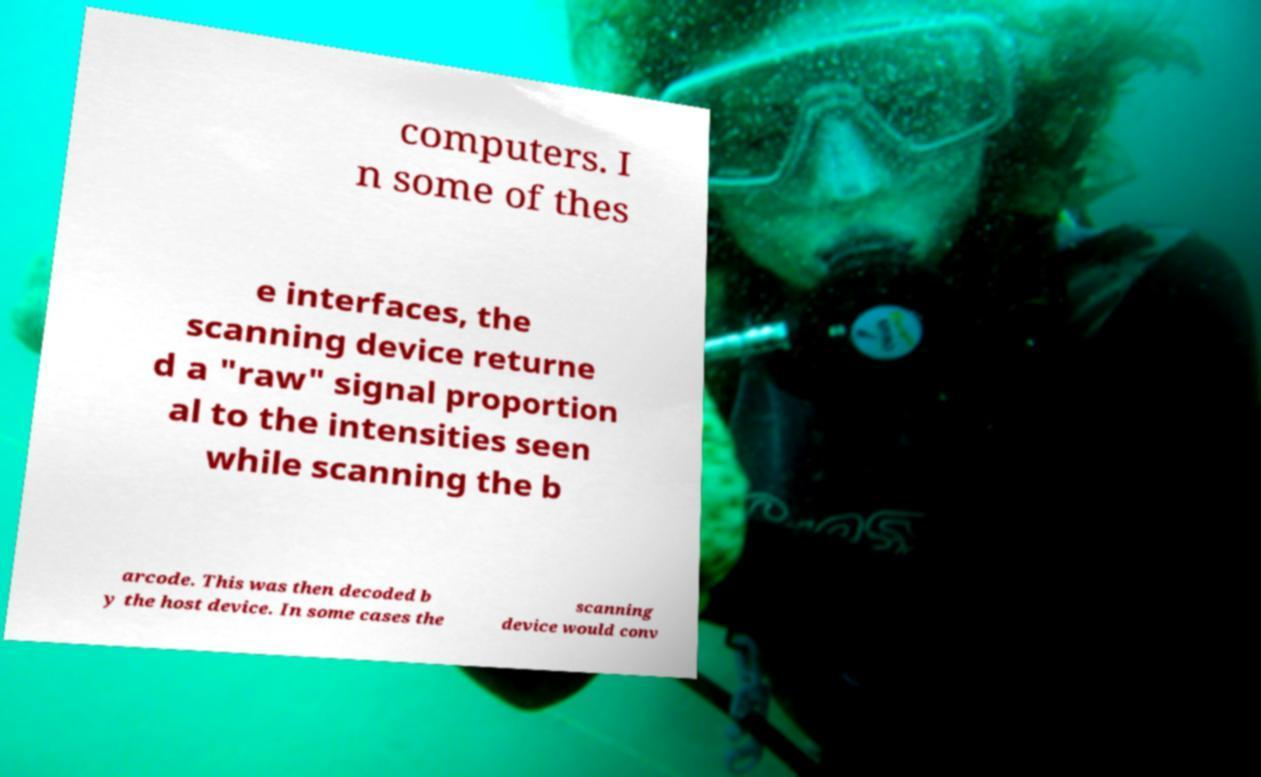What messages or text are displayed in this image? I need them in a readable, typed format. computers. I n some of thes e interfaces, the scanning device returne d a "raw" signal proportion al to the intensities seen while scanning the b arcode. This was then decoded b y the host device. In some cases the scanning device would conv 